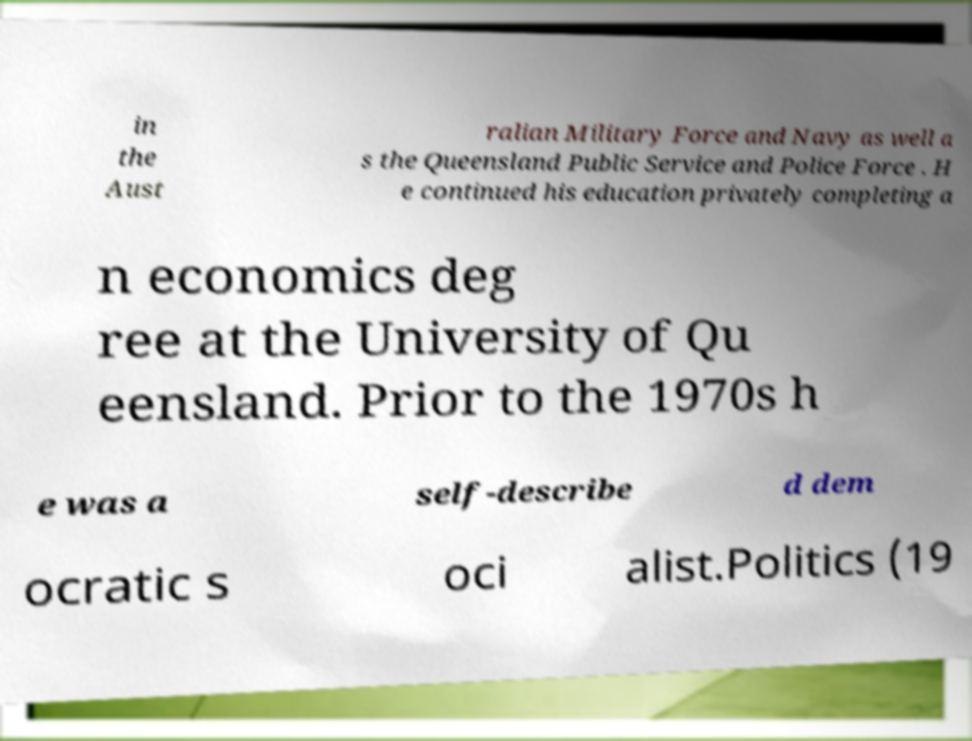What messages or text are displayed in this image? I need them in a readable, typed format. in the Aust ralian Military Force and Navy as well a s the Queensland Public Service and Police Force . H e continued his education privately completing a n economics deg ree at the University of Qu eensland. Prior to the 1970s h e was a self-describe d dem ocratic s oci alist.Politics (19 